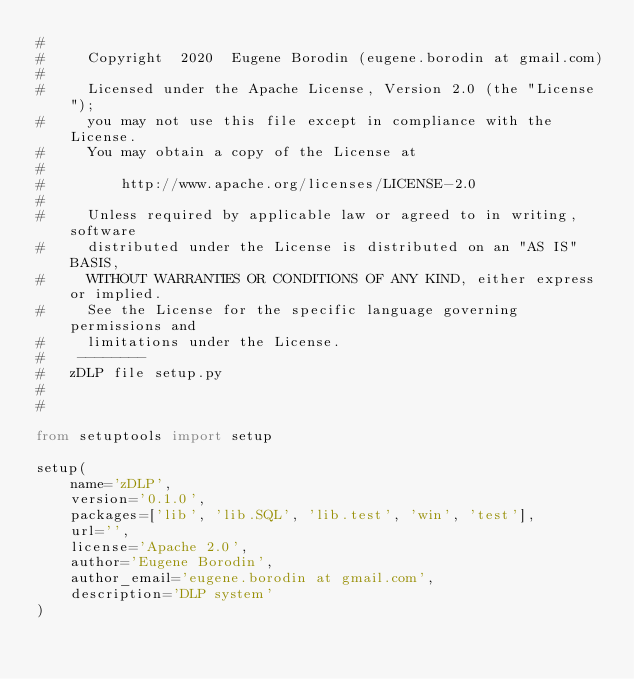<code> <loc_0><loc_0><loc_500><loc_500><_Python_>#
#     Copyright  2020  Eugene Borodin (eugene.borodin at gmail.com)
#
#     Licensed under the Apache License, Version 2.0 (the "License");
#     you may not use this file except in compliance with the License.
#     You may obtain a copy of the License at
#
#         http://www.apache.org/licenses/LICENSE-2.0
#
#     Unless required by applicable law or agreed to in writing, software
#     distributed under the License is distributed on an "AS IS" BASIS,
#     WITHOUT WARRANTIES OR CONDITIONS OF ANY KIND, either express or implied.
#     See the License for the specific language governing permissions and
#     limitations under the License.
#    --------
#   zDLP file setup.py
#
#

from setuptools import setup

setup(
    name='zDLP',
    version='0.1.0',
    packages=['lib', 'lib.SQL', 'lib.test', 'win', 'test'],
    url='',
    license='Apache 2.0',
    author='Eugene Borodin',
    author_email='eugene.borodin at gmail.com',
    description='DLP system'
)
</code> 